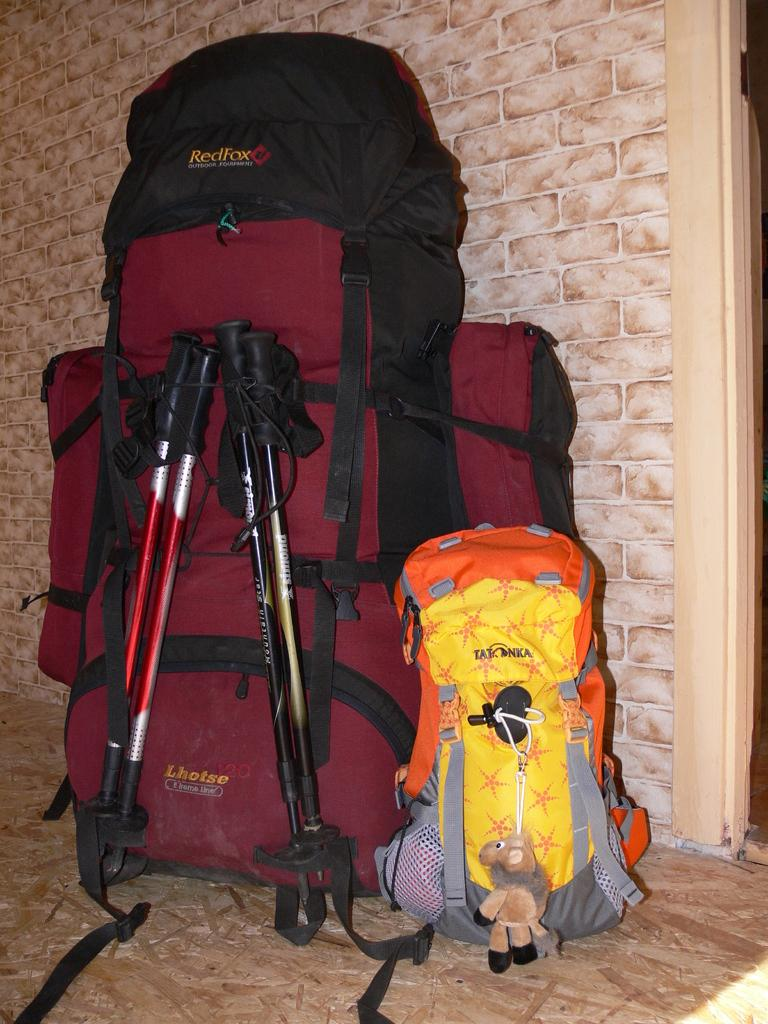<image>
Create a compact narrative representing the image presented. two backpacks on the floor with one being a RedFox brand 